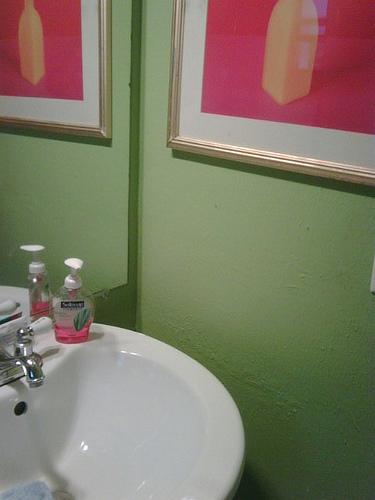What color are the walls?
Keep it brief. Green. How many sinks in the picture?
Quick response, please. 1. What color is the liquid hand soap?
Give a very brief answer. Pink. What color is the frame?
Give a very brief answer. Gold. Is there a mirror in this picture?
Quick response, please. Yes. 